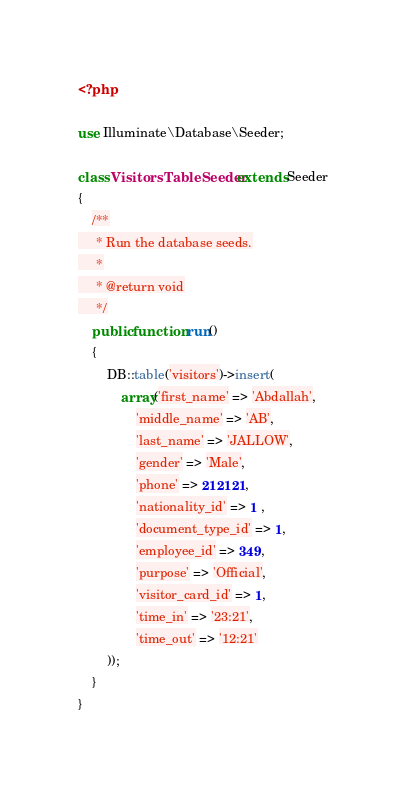Convert code to text. <code><loc_0><loc_0><loc_500><loc_500><_PHP_><?php

use Illuminate\Database\Seeder;

class VisitorsTableSeeder extends Seeder
{
    /**
     * Run the database seeds.
     *
     * @return void
     */
    public function run()
    {
        DB::table('visitors')->insert(
            array('first_name' => 'Abdallah',
                'middle_name' => 'AB',
                'last_name' => 'JALLOW',
                'gender' => 'Male',
                'phone' => 212121,
                'nationality_id' => 1 ,
                'document_type_id' => 1,
                'employee_id' => 349,
                'purpose' => 'Official',
                'visitor_card_id' => 1,
                'time_in' => '23:21',
                'time_out' => '12:21'
        ));
    }
}
</code> 